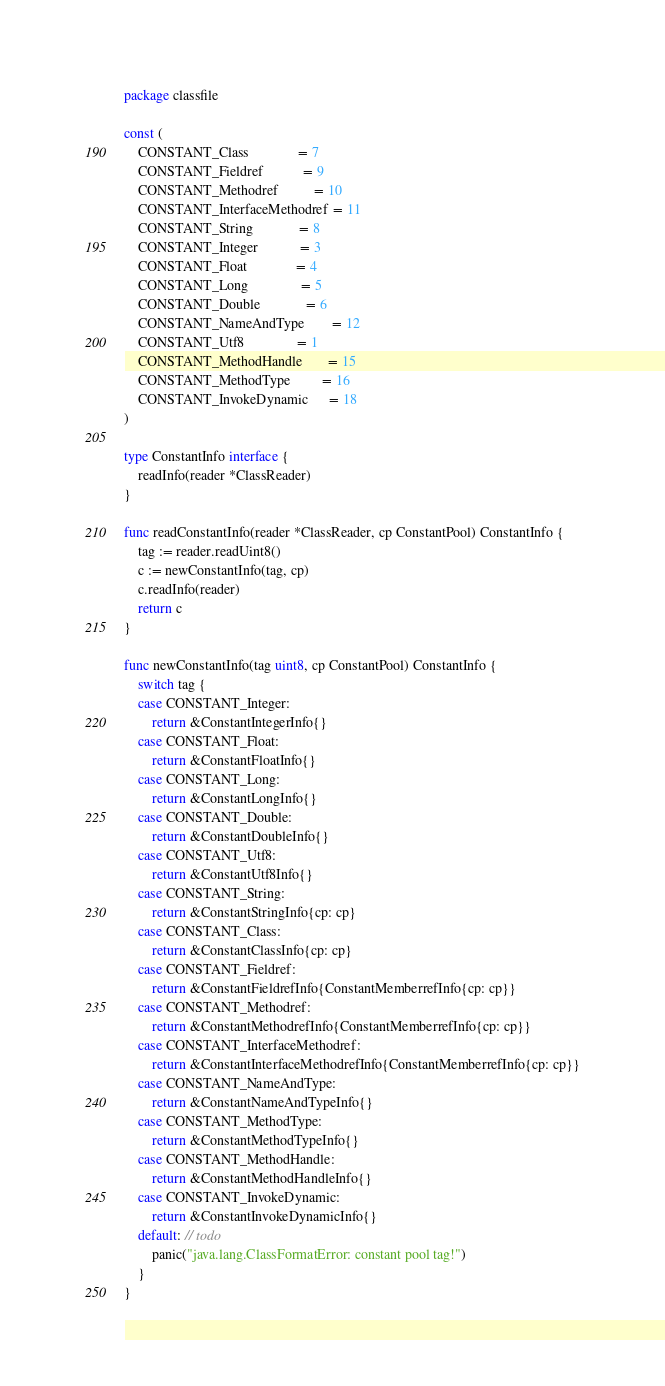Convert code to text. <code><loc_0><loc_0><loc_500><loc_500><_Go_>package classfile

const (
	CONSTANT_Class              = 7
	CONSTANT_Fieldref           = 9
	CONSTANT_Methodref          = 10
	CONSTANT_InterfaceMethodref = 11
	CONSTANT_String             = 8
	CONSTANT_Integer            = 3
	CONSTANT_Float              = 4
	CONSTANT_Long               = 5
	CONSTANT_Double             = 6
	CONSTANT_NameAndType        = 12
	CONSTANT_Utf8               = 1
	CONSTANT_MethodHandle       = 15
	CONSTANT_MethodType         = 16
	CONSTANT_InvokeDynamic      = 18
)

type ConstantInfo interface {
	readInfo(reader *ClassReader)
}

func readConstantInfo(reader *ClassReader, cp ConstantPool) ConstantInfo {
	tag := reader.readUint8()
	c := newConstantInfo(tag, cp)
	c.readInfo(reader)
	return c
}

func newConstantInfo(tag uint8, cp ConstantPool) ConstantInfo {
	switch tag {
	case CONSTANT_Integer:
		return &ConstantIntegerInfo{}
	case CONSTANT_Float:
		return &ConstantFloatInfo{}
	case CONSTANT_Long:
		return &ConstantLongInfo{}
	case CONSTANT_Double:
		return &ConstantDoubleInfo{}
	case CONSTANT_Utf8:
		return &ConstantUtf8Info{}
	case CONSTANT_String:
		return &ConstantStringInfo{cp: cp}
	case CONSTANT_Class:
		return &ConstantClassInfo{cp: cp}
	case CONSTANT_Fieldref:
		return &ConstantFieldrefInfo{ConstantMemberrefInfo{cp: cp}}
	case CONSTANT_Methodref:
		return &ConstantMethodrefInfo{ConstantMemberrefInfo{cp: cp}}
	case CONSTANT_InterfaceMethodref:
		return &ConstantInterfaceMethodrefInfo{ConstantMemberrefInfo{cp: cp}}
	case CONSTANT_NameAndType:
		return &ConstantNameAndTypeInfo{}
	case CONSTANT_MethodType:
		return &ConstantMethodTypeInfo{}
	case CONSTANT_MethodHandle:
		return &ConstantMethodHandleInfo{}
	case CONSTANT_InvokeDynamic:
		return &ConstantInvokeDynamicInfo{}
	default: // todo
		panic("java.lang.ClassFormatError: constant pool tag!")
	}
}
</code> 